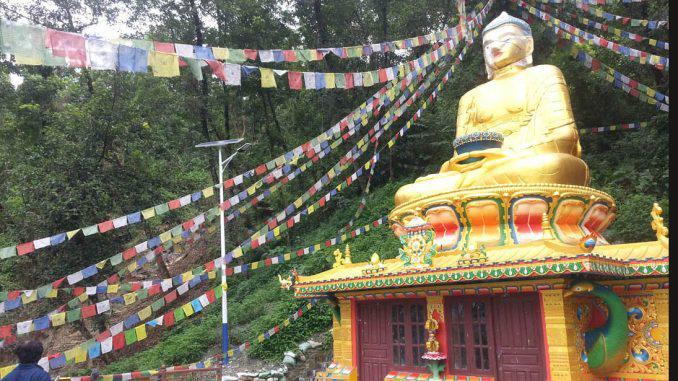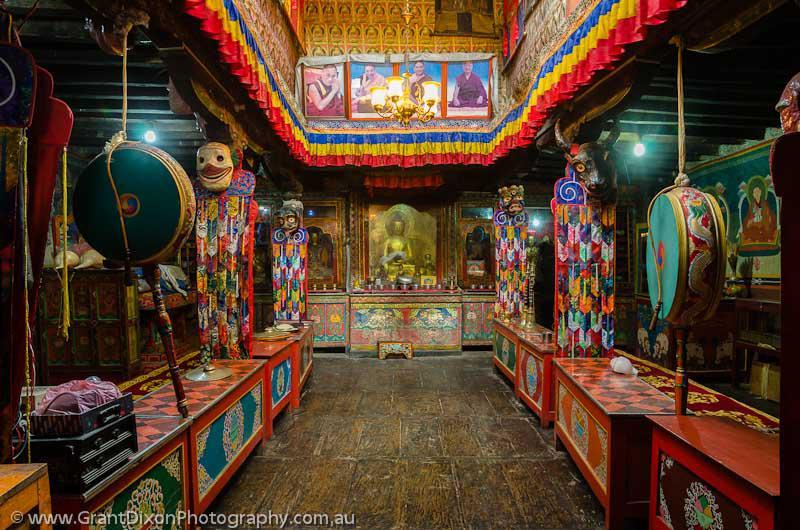The first image is the image on the left, the second image is the image on the right. Considering the images on both sides, is "An image shows a string of colored flags suspended near a building with hills and trees behind it." valid? Answer yes or no. Yes. The first image is the image on the left, the second image is the image on the right. Analyze the images presented: Is the assertion "Each image shows the outside of a building, no statues or indoors." valid? Answer yes or no. No. 